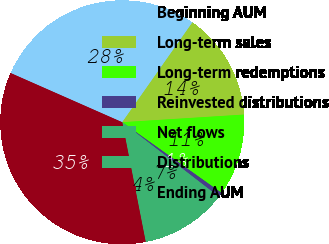<chart> <loc_0><loc_0><loc_500><loc_500><pie_chart><fcel>Beginning AUM<fcel>Long-term sales<fcel>Long-term redemptions<fcel>Reinvested distributions<fcel>Net flows<fcel>Distributions<fcel>Ending AUM<nl><fcel>28.15%<fcel>14.25%<fcel>10.84%<fcel>0.62%<fcel>7.43%<fcel>4.03%<fcel>34.69%<nl></chart> 